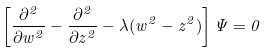<formula> <loc_0><loc_0><loc_500><loc_500>\left [ \frac { \partial ^ { 2 } } { \partial w ^ { 2 } } - \frac { \partial ^ { 2 } } { \partial z ^ { 2 } } - \lambda ( w ^ { 2 } - z ^ { 2 } ) \right ] \Psi = 0</formula> 